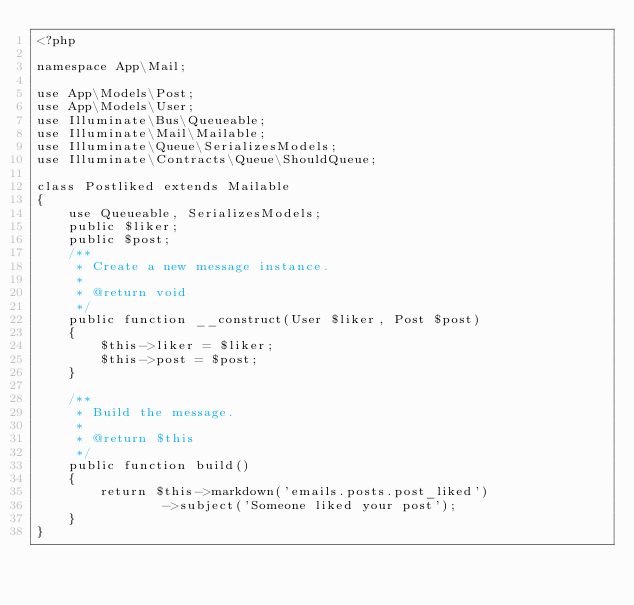<code> <loc_0><loc_0><loc_500><loc_500><_PHP_><?php

namespace App\Mail;

use App\Models\Post;
use App\Models\User;
use Illuminate\Bus\Queueable;
use Illuminate\Mail\Mailable;
use Illuminate\Queue\SerializesModels;
use Illuminate\Contracts\Queue\ShouldQueue;

class Postliked extends Mailable
{
    use Queueable, SerializesModels;
    public $liker;
    public $post;
    /**
     * Create a new message instance.
     *
     * @return void
     */
    public function __construct(User $liker, Post $post)
    {
        $this->liker = $liker;
        $this->post = $post;
    }

    /**
     * Build the message.
     *
     * @return $this
     */
    public function build()
    {
        return $this->markdown('emails.posts.post_liked')
                ->subject('Someone liked your post');
    }
}
</code> 